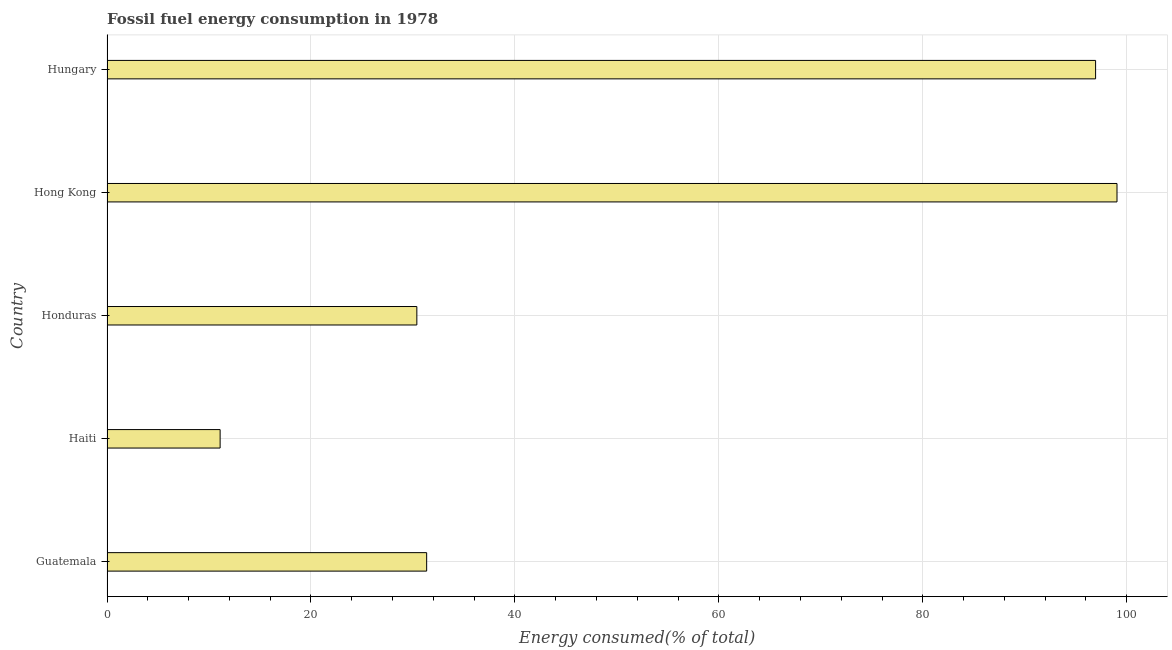Does the graph contain any zero values?
Ensure brevity in your answer.  No. Does the graph contain grids?
Provide a short and direct response. Yes. What is the title of the graph?
Offer a very short reply. Fossil fuel energy consumption in 1978. What is the label or title of the X-axis?
Your response must be concise. Energy consumed(% of total). What is the label or title of the Y-axis?
Offer a very short reply. Country. What is the fossil fuel energy consumption in Honduras?
Provide a short and direct response. 30.38. Across all countries, what is the maximum fossil fuel energy consumption?
Give a very brief answer. 99.04. Across all countries, what is the minimum fossil fuel energy consumption?
Keep it short and to the point. 11.09. In which country was the fossil fuel energy consumption maximum?
Offer a terse response. Hong Kong. In which country was the fossil fuel energy consumption minimum?
Make the answer very short. Haiti. What is the sum of the fossil fuel energy consumption?
Provide a succinct answer. 268.81. What is the difference between the fossil fuel energy consumption in Haiti and Hungary?
Your response must be concise. -85.85. What is the average fossil fuel energy consumption per country?
Make the answer very short. 53.76. What is the median fossil fuel energy consumption?
Give a very brief answer. 31.35. What is the ratio of the fossil fuel energy consumption in Guatemala to that in Hong Kong?
Your answer should be compact. 0.32. Is the fossil fuel energy consumption in Guatemala less than that in Hungary?
Provide a succinct answer. Yes. What is the difference between the highest and the second highest fossil fuel energy consumption?
Give a very brief answer. 2.1. What is the difference between the highest and the lowest fossil fuel energy consumption?
Provide a succinct answer. 87.95. Are all the bars in the graph horizontal?
Offer a terse response. Yes. How many countries are there in the graph?
Your response must be concise. 5. Are the values on the major ticks of X-axis written in scientific E-notation?
Offer a very short reply. No. What is the Energy consumed(% of total) of Guatemala?
Your response must be concise. 31.35. What is the Energy consumed(% of total) in Haiti?
Offer a very short reply. 11.09. What is the Energy consumed(% of total) in Honduras?
Your answer should be compact. 30.38. What is the Energy consumed(% of total) of Hong Kong?
Keep it short and to the point. 99.04. What is the Energy consumed(% of total) of Hungary?
Ensure brevity in your answer.  96.94. What is the difference between the Energy consumed(% of total) in Guatemala and Haiti?
Offer a very short reply. 20.25. What is the difference between the Energy consumed(% of total) in Guatemala and Honduras?
Your response must be concise. 0.96. What is the difference between the Energy consumed(% of total) in Guatemala and Hong Kong?
Provide a succinct answer. -67.7. What is the difference between the Energy consumed(% of total) in Guatemala and Hungary?
Keep it short and to the point. -65.6. What is the difference between the Energy consumed(% of total) in Haiti and Honduras?
Make the answer very short. -19.29. What is the difference between the Energy consumed(% of total) in Haiti and Hong Kong?
Ensure brevity in your answer.  -87.95. What is the difference between the Energy consumed(% of total) in Haiti and Hungary?
Offer a terse response. -85.85. What is the difference between the Energy consumed(% of total) in Honduras and Hong Kong?
Your answer should be very brief. -68.66. What is the difference between the Energy consumed(% of total) in Honduras and Hungary?
Offer a very short reply. -66.56. What is the difference between the Energy consumed(% of total) in Hong Kong and Hungary?
Your answer should be compact. 2.1. What is the ratio of the Energy consumed(% of total) in Guatemala to that in Haiti?
Offer a very short reply. 2.83. What is the ratio of the Energy consumed(% of total) in Guatemala to that in Honduras?
Offer a terse response. 1.03. What is the ratio of the Energy consumed(% of total) in Guatemala to that in Hong Kong?
Ensure brevity in your answer.  0.32. What is the ratio of the Energy consumed(% of total) in Guatemala to that in Hungary?
Your answer should be compact. 0.32. What is the ratio of the Energy consumed(% of total) in Haiti to that in Honduras?
Your response must be concise. 0.36. What is the ratio of the Energy consumed(% of total) in Haiti to that in Hong Kong?
Give a very brief answer. 0.11. What is the ratio of the Energy consumed(% of total) in Haiti to that in Hungary?
Make the answer very short. 0.11. What is the ratio of the Energy consumed(% of total) in Honduras to that in Hong Kong?
Give a very brief answer. 0.31. What is the ratio of the Energy consumed(% of total) in Honduras to that in Hungary?
Your response must be concise. 0.31. 